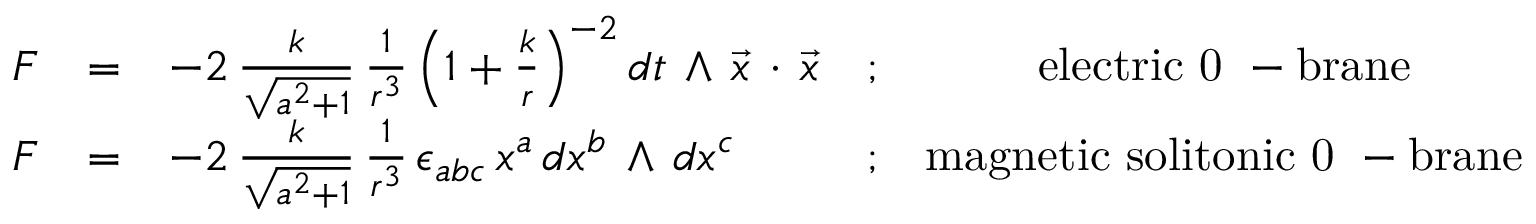Convert formula to latex. <formula><loc_0><loc_0><loc_500><loc_500>\begin{array} { r c l c c } { F } & { = } & { { - 2 \, \frac { k } { \sqrt { a ^ { 2 } + 1 } } \, \frac { 1 } { r ^ { 3 } } \left ( 1 + \frac { k } { r } \right ) ^ { - 2 } d t \, \wedge \, { \vec { x } } \, \cdot \, { \vec { x } } } } & { ; } & { e l e c t r i c 0 - b r a n e } \\ { F } & { = } & { { - 2 \, \frac { k } { \sqrt { a ^ { 2 } + 1 } } \, \frac { 1 } { r ^ { 3 } } \, \epsilon _ { a b c } \, x ^ { a } \, d x ^ { b } \, \wedge \, d x ^ { c } } } & { ; } & { m a g n e t i c s o l i t o n i c 0 - b r a n e } \end{array}</formula> 